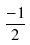Convert formula to latex. <formula><loc_0><loc_0><loc_500><loc_500>\frac { - 1 } { 2 }</formula> 